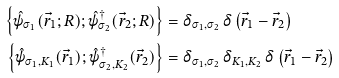Convert formula to latex. <formula><loc_0><loc_0><loc_500><loc_500>\left \{ \hat { \psi } _ { \sigma _ { 1 } } ( \vec { r } _ { 1 } ; R ) ; \hat { \psi } _ { \sigma _ { 2 } } ^ { \dagger } ( \vec { r } _ { 2 } ; R ) \right \} & = \delta _ { \sigma _ { 1 } , \sigma _ { 2 } } \, \delta \left ( \vec { r } _ { 1 } - \vec { r } _ { 2 } \right ) \\ \left \{ \hat { \psi } _ { \sigma _ { 1 } , K _ { 1 } } ( \vec { r } _ { 1 } ) ; \hat { \psi } _ { \sigma _ { 2 } , K _ { 2 } } ^ { \dagger } ( \vec { r } _ { 2 } ) \right \} & = \delta _ { \sigma _ { 1 } , \sigma _ { 2 } } \, \delta _ { K _ { 1 } , K _ { 2 } } \, \delta \left ( \vec { r } _ { 1 } - \vec { r } _ { 2 } \right )</formula> 